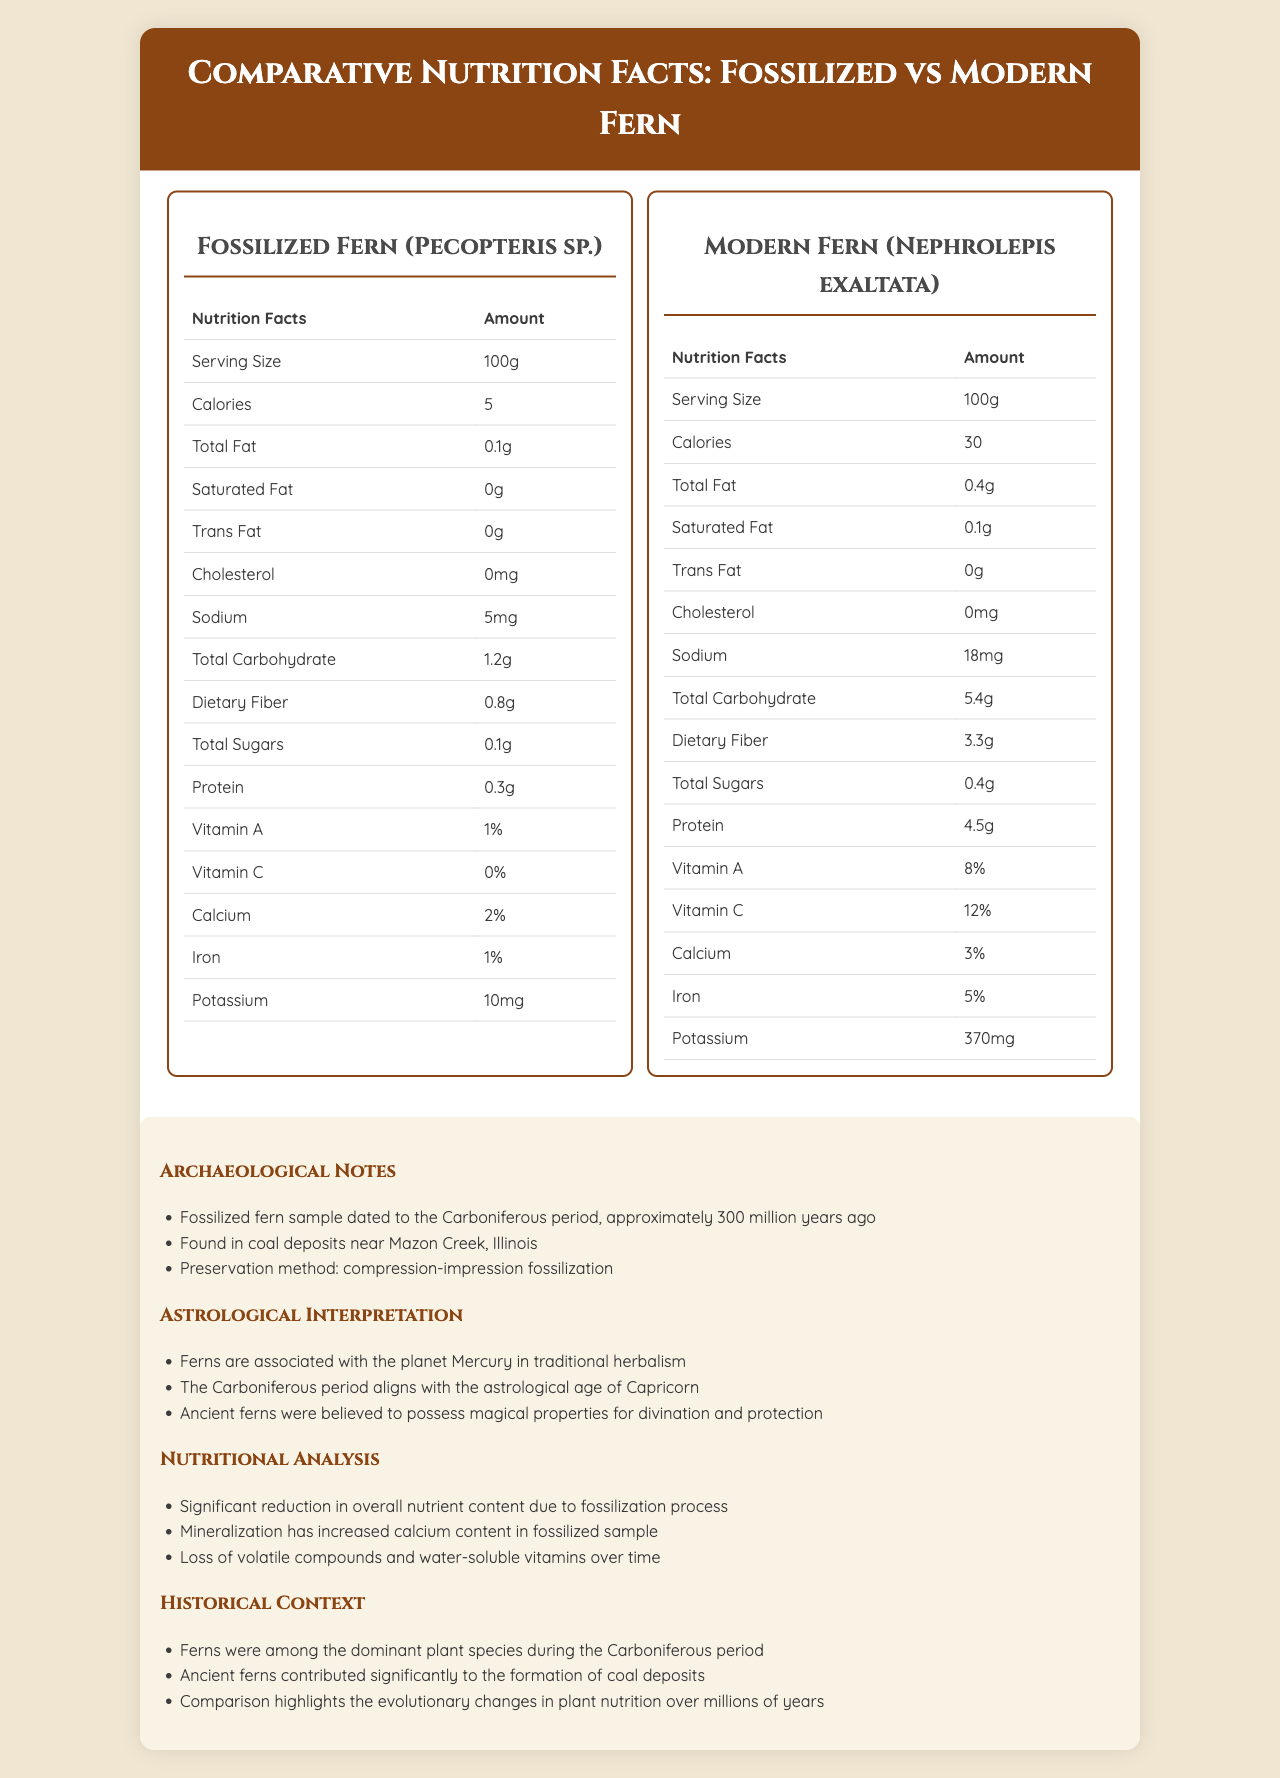what is the serving size of both ferns? The serving size is specified as "100g" for both the fossilized fern and the modern fern.
Answer: 100g what is the caloric difference between the fossilized fern and the modern fern? The fossilized fern has 5 calories while the modern fern has 30 calories, making a 25-calorie difference.
Answer: 25 calories how much protein does the modern fern contain? The amount of protein in the modern fern is listed as 4.5g.
Answer: 4.5g what is the amount of potassium in the fossilized fern? The amount of potassium in the fossilized fern is listed as 10mg.
Answer: 10mg what period is the fossilized fern sample dated to? The fossilized fern sample is dated to the Carboniferous period.
Answer: Carboniferous period which fern has a higher sodium content? A. Fossilized Fern B. Modern Fern C. Neither The modern fern contains 18mg of sodium, which is higher than the fossilized fern's 5mg of sodium.
Answer: B. Modern Fern which vitamin shows a greater percentage in the modern fern compared to the fossilized fern? I. Vitamin A II. Vitamin C III. Both Vitamin A is 8% in the modern fern vs. 1% in the fossilized fern, and Vitamin C is 12% in the modern fern vs. 0% in the fossilized fern.
Answer: III. Both are there any trans fats in the fossilized fern? The document indicates that both the fossilized fern and modern fern contain 0g of trans fats.
Answer: No summarize the main nutritional differences between the fossilized fern and modern fern. The detailed comparison highlights the impact of fossilization on nutrient content and provides insights into the evolutionary nutritional changes.
Answer: The modern fern has significantly higher values in almost all nutritional categories compared to the fossilized fern, including calories, fats, carbohydrates, dietary fiber, sugars, protein, vitamins A and C, iron, and potassium. The fossilized fern, though, has decreased nutrient content due to the fossilization process with some mineral content being higher due to mineralization. what is the role of ferns during the Carboniferous period? The historical context notes that ferns were among the dominant plant species during the Carboniferous period and significantly contributed to the formation of coal deposits.
Answer: Dominant plant species and contributors to coal deposits what was the preservation method used for the fossilized fern? The document specifies that the fossilized fern was preserved using compression-impression fossilization.
Answer: Compression-impression fossilization what kind of interpretation associates ferns with the planet Mercury? The document mentions that ferns are associated with the planet Mercury in traditional herbalism, which is part of the astrological interpretation.
Answer: Astrological interpretation how does the nutritional content reduction occur in fossilized plants? The nutritional analysis indicates that significant reduction in overall nutrient content occurs due to the fossilization process and the loss of volatile compounds and water-soluble vitamins over time.
Answer: Due to fossilization and mineralization processes which period aligns with the astrological age of Capricorn? The astrological interpretation notes that the Carboniferous period aligns with the astrological age of Capricorn.
Answer: Carboniferous period how many calories are in the fossilized fern? The document lists the fossilized fern as containing 5 calories.
Answer: 5 calories which fern has a higher iron content percentage? The modern fern has 5% iron content compared to the fossilized fern's 1%.
Answer: Modern Fern how is coal formation related to ancient ferns? The historical context explains that ancient ferns were dominant and significantly contributed to coal formation.
Answer: Ancient ferns contributed significantly to the formation of coal deposits during the Carboniferous period. where were the fossilized fern samples found? The archaeological notes indicate that the fossilized fern sample was found in coal deposits near Mazon Creek, Illinois.
Answer: Mazon Creek, Illinois which vitamin shows no percentage in the fossilized fern? The document lists Vitamin C as 0% in the fossilized fern.
Answer: Vitamin C what kind of minerals increased in the fossilized sample? The document notes that mineralization has increased the calcium content in the fossilized sample.
Answer: Calcium does the modern fern contain cholesterol? The document lists 0mg of cholesterol for both the fossilized and modern ferns.
Answer: No is there enough information to determine the exact impact of fossilization on specific nutrient categories? The document provides comparative analysis but does not delve into specific scientific explanations or quantitative impact measures of fossilization on each nutrient category.
Answer: Not enough information 